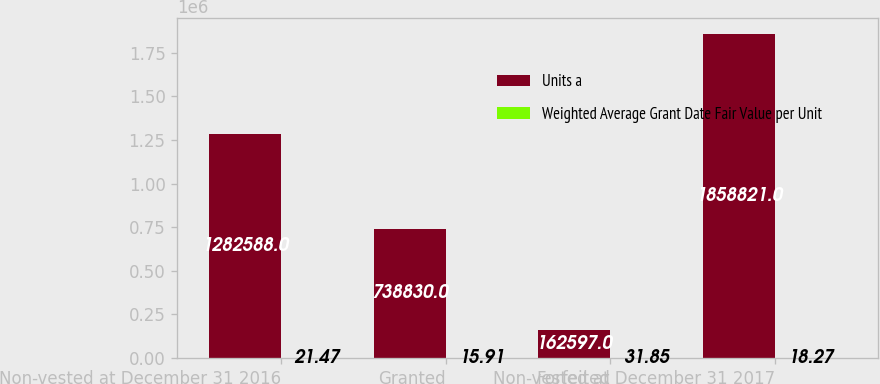<chart> <loc_0><loc_0><loc_500><loc_500><stacked_bar_chart><ecel><fcel>Non-vested at December 31 2016<fcel>Granted<fcel>Forfeited<fcel>Non-vested at December 31 2017<nl><fcel>Units a<fcel>1.28259e+06<fcel>738830<fcel>162597<fcel>1.85882e+06<nl><fcel>Weighted Average Grant Date Fair Value per Unit<fcel>21.47<fcel>15.91<fcel>31.85<fcel>18.27<nl></chart> 